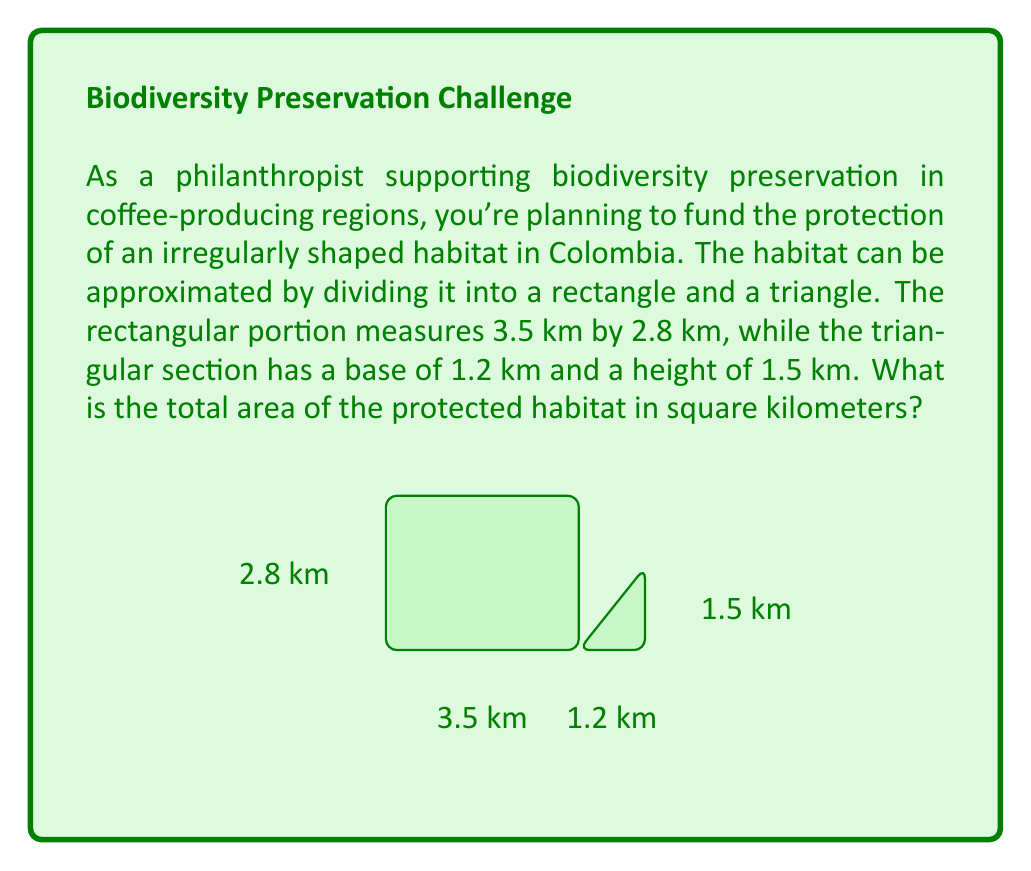What is the answer to this math problem? To solve this problem, we need to calculate the areas of the rectangular and triangular portions separately, then add them together.

1. Area of the rectangle:
   $$ A_{rectangle} = length \times width $$
   $$ A_{rectangle} = 3.5 \text{ km} \times 2.8 \text{ km} = 9.8 \text{ km}^2 $$

2. Area of the triangle:
   $$ A_{triangle} = \frac{1}{2} \times base \times height $$
   $$ A_{triangle} = \frac{1}{2} \times 1.2 \text{ km} \times 1.5 \text{ km} = 0.9 \text{ km}^2 $$

3. Total area of the habitat:
   $$ A_{total} = A_{rectangle} + A_{triangle} $$
   $$ A_{total} = 9.8 \text{ km}^2 + 0.9 \text{ km}^2 = 10.7 \text{ km}^2 $$

Therefore, the total area of the protected habitat is 10.7 square kilometers.
Answer: $10.7 \text{ km}^2$ 